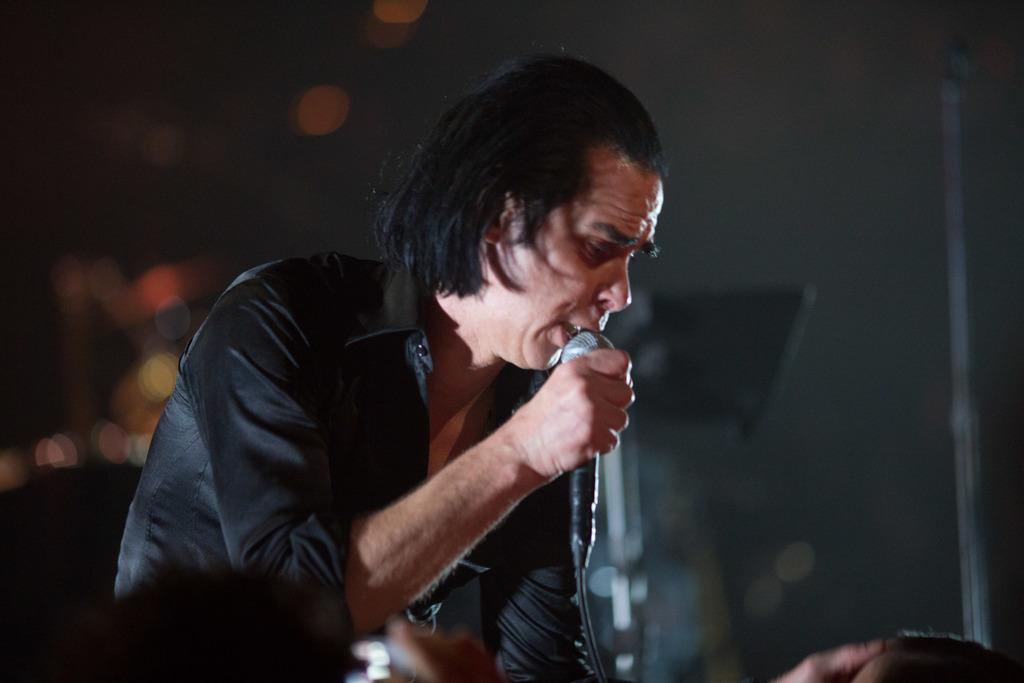What is the main subject of the image? There is a person in the image. What is the person holding in the image? The person is holding a mic. Are there any bears visible in the image? No, there are no bears present in the image. What type of destruction can be seen happening to the mic in the image? There is no destruction happening to the mic in the image; it is being held by the person. 